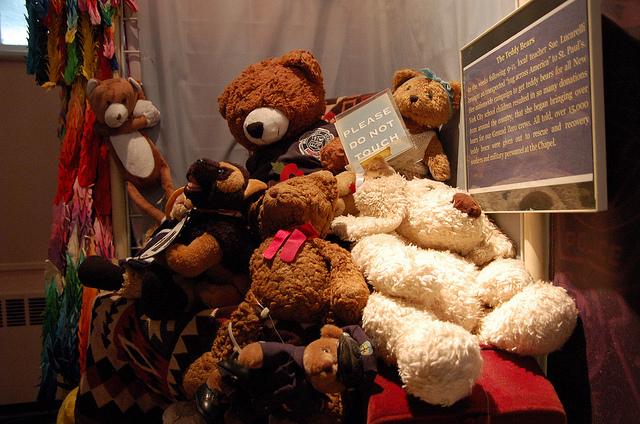Are any bears wearing sunglasses?
Keep it brief. No. The teddy bear in the top right is wearing a bow with what color?
Concise answer only. Blue. Where are the bears hung?
Concise answer only. Museum. Should we touch these teddy bears?
Answer briefly. No. Do you see a sign?
Write a very short answer. Yes. How many bears are there?
Give a very brief answer. 7. How many bears are really in the picture?
Quick response, please. 7. Are the bears dirty?
Give a very brief answer. No. How many rows of bears are visible?
Be succinct. 2. Are the bears dressed in costume?
Be succinct. No. 